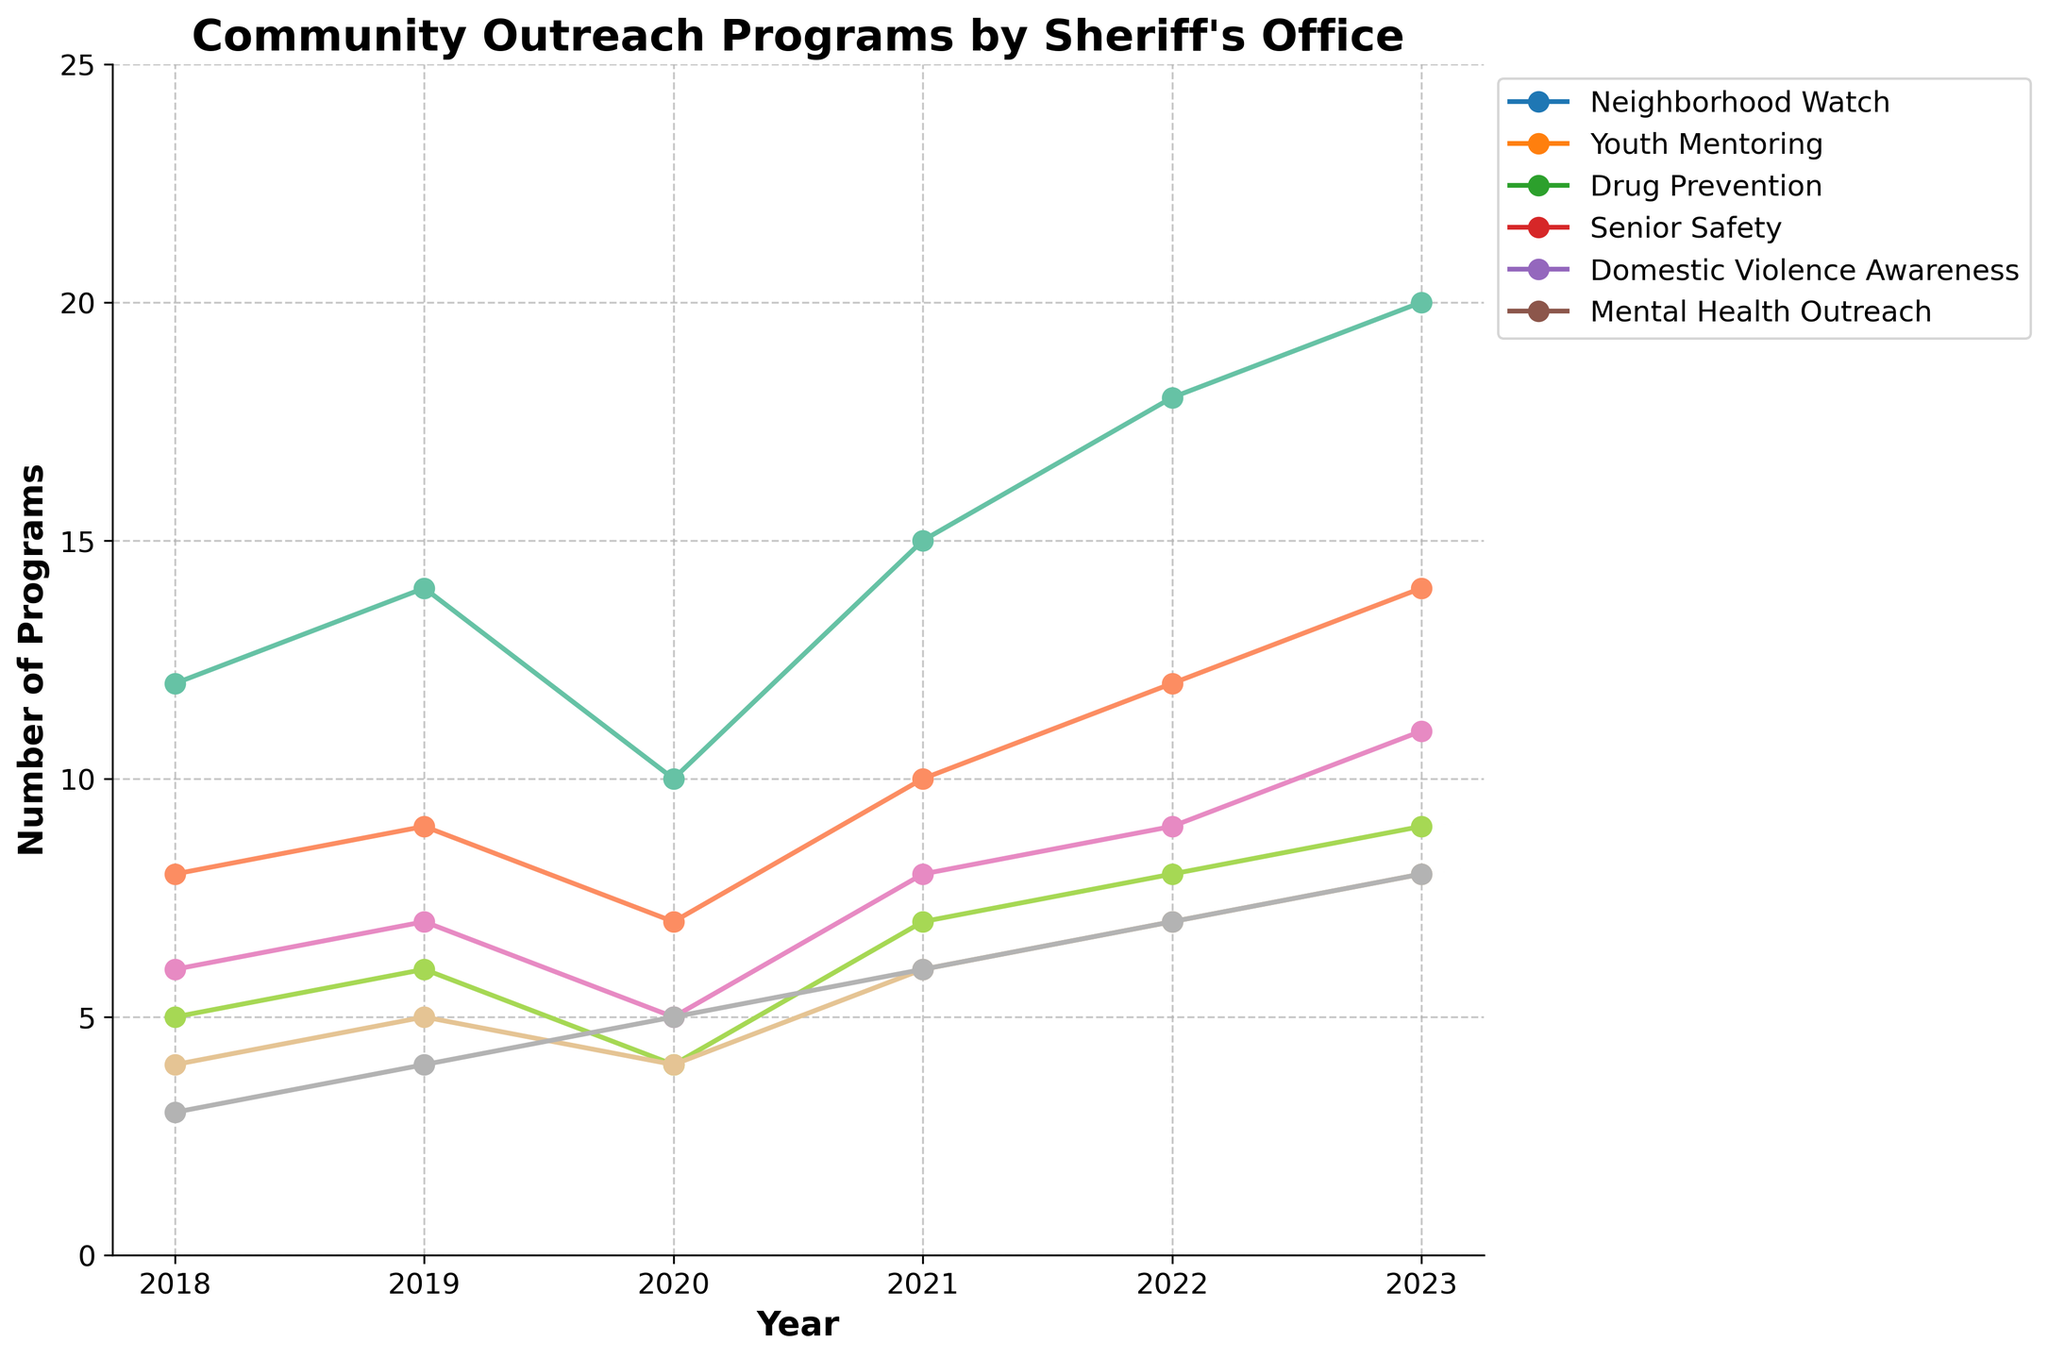Which year had the highest number of Youth Mentoring programs? The highest point on the Youth Mentoring line on the graph corresponds to the year. Looking at the line for Youth Mentoring, the highest point falls in 2023.
Answer: 2023 Between 2018 and 2023, which program saw the least increase in the number of implementations? Calculate the difference between the numbers for each program in 2023 and 2018. Mental Health Outreach increased by (8-3)=5, Neighborhood Watch by (20-12)=8, and similarly for others. The smallest increase is for Mental Health Outreach.
Answer: Mental Health Outreach What is the total number of programs implemented in 2022 across all program types? Sum the numbers for each program type in 2022: 18 (Neighborhood Watch) + 12 (Youth Mentoring) + 9 (Drug Prevention) + 8 (Senior Safety) + 7 (Domestic Violence Awareness) + 7 (Mental Health Outreach) = 61.
Answer: 61 Which program experienced the least fluctuation in numbers from 2018 to 2023? Fluctuation is observed by the changes in the line heights. Mental Health Outreach shows a consistently small increment year by year.
Answer: Mental Health Outreach In which year did Domestic Violence Awareness programs first exceed 6 implementations? Identify when the line for Domestic Violence Awareness crosses above 6. It first exceeds 6 in 2021.
Answer: 2021 